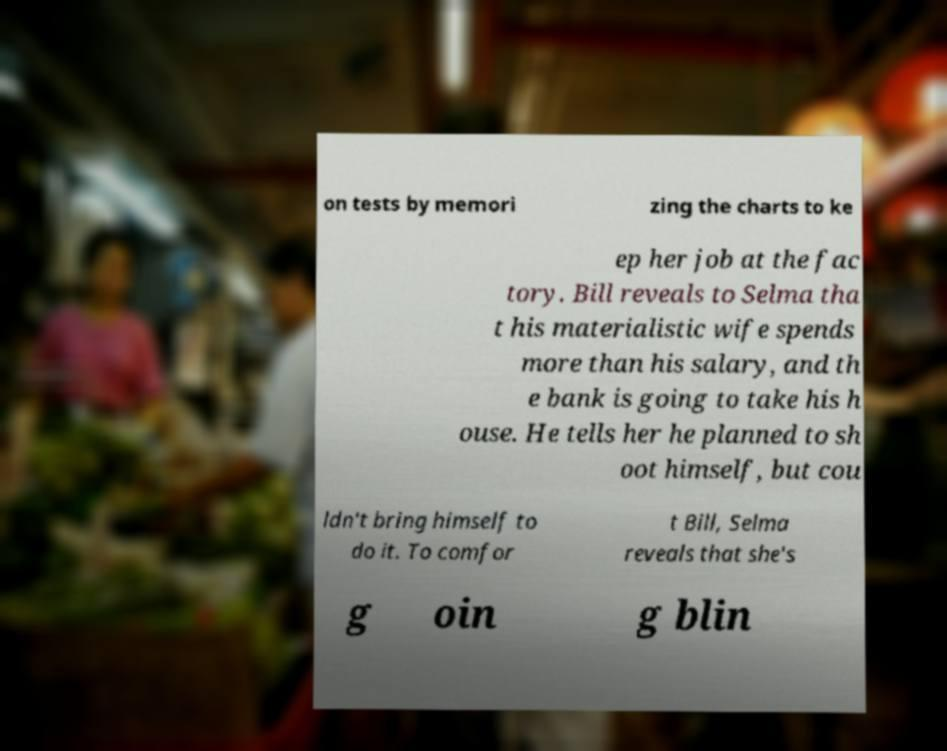Can you accurately transcribe the text from the provided image for me? on tests by memori zing the charts to ke ep her job at the fac tory. Bill reveals to Selma tha t his materialistic wife spends more than his salary, and th e bank is going to take his h ouse. He tells her he planned to sh oot himself, but cou ldn't bring himself to do it. To comfor t Bill, Selma reveals that she's g oin g blin 